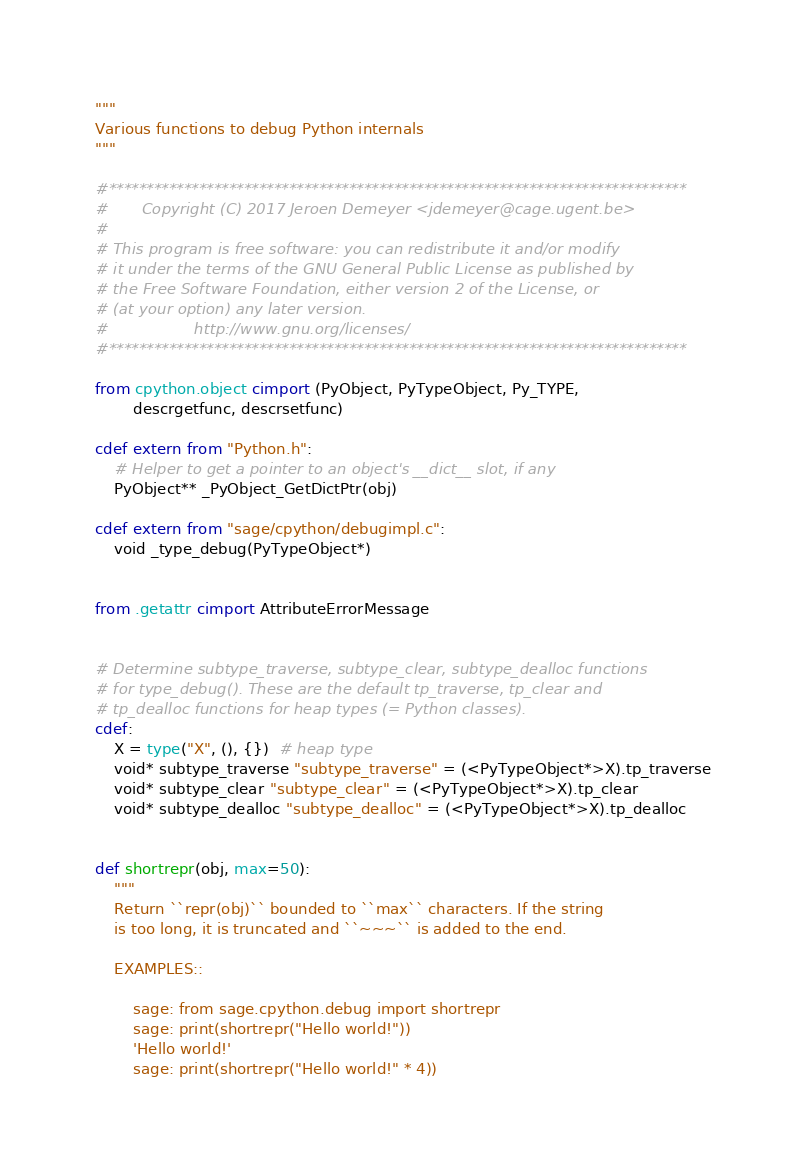Convert code to text. <code><loc_0><loc_0><loc_500><loc_500><_Cython_>"""
Various functions to debug Python internals
"""

#*****************************************************************************
#       Copyright (C) 2017 Jeroen Demeyer <jdemeyer@cage.ugent.be>
#
# This program is free software: you can redistribute it and/or modify
# it under the terms of the GNU General Public License as published by
# the Free Software Foundation, either version 2 of the License, or
# (at your option) any later version.
#                  http://www.gnu.org/licenses/
#*****************************************************************************

from cpython.object cimport (PyObject, PyTypeObject, Py_TYPE,
        descrgetfunc, descrsetfunc)

cdef extern from "Python.h":
    # Helper to get a pointer to an object's __dict__ slot, if any
    PyObject** _PyObject_GetDictPtr(obj)

cdef extern from "sage/cpython/debugimpl.c":
    void _type_debug(PyTypeObject*)


from .getattr cimport AttributeErrorMessage


# Determine subtype_traverse, subtype_clear, subtype_dealloc functions
# for type_debug(). These are the default tp_traverse, tp_clear and
# tp_dealloc functions for heap types (= Python classes).
cdef:
    X = type("X", (), {})  # heap type
    void* subtype_traverse "subtype_traverse" = (<PyTypeObject*>X).tp_traverse
    void* subtype_clear "subtype_clear" = (<PyTypeObject*>X).tp_clear
    void* subtype_dealloc "subtype_dealloc" = (<PyTypeObject*>X).tp_dealloc


def shortrepr(obj, max=50):
    """
    Return ``repr(obj)`` bounded to ``max`` characters. If the string
    is too long, it is truncated and ``~~~`` is added to the end.

    EXAMPLES::

        sage: from sage.cpython.debug import shortrepr
        sage: print(shortrepr("Hello world!"))
        'Hello world!'
        sage: print(shortrepr("Hello world!" * 4))</code> 